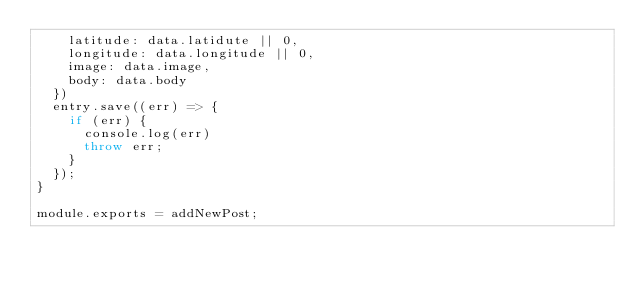<code> <loc_0><loc_0><loc_500><loc_500><_JavaScript_>    latitude: data.latidute || 0,
    longitude: data.longitude || 0,
    image: data.image,
    body: data.body
  })
  entry.save((err) => {
    if (err) {
      console.log(err)
      throw err;
    }
  });
}

module.exports = addNewPost;</code> 